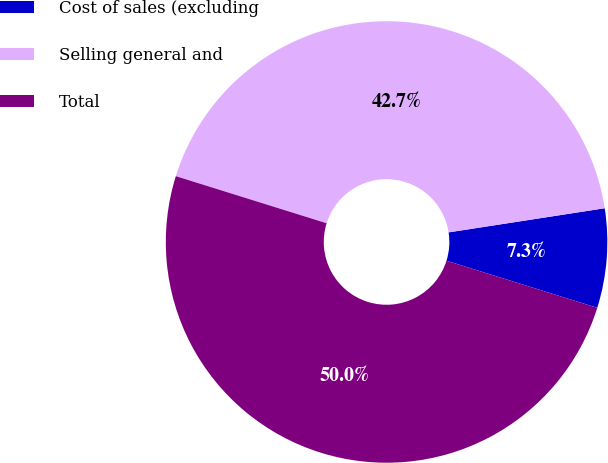Convert chart to OTSL. <chart><loc_0><loc_0><loc_500><loc_500><pie_chart><fcel>Cost of sales (excluding<fcel>Selling general and<fcel>Total<nl><fcel>7.26%<fcel>42.74%<fcel>50.0%<nl></chart> 